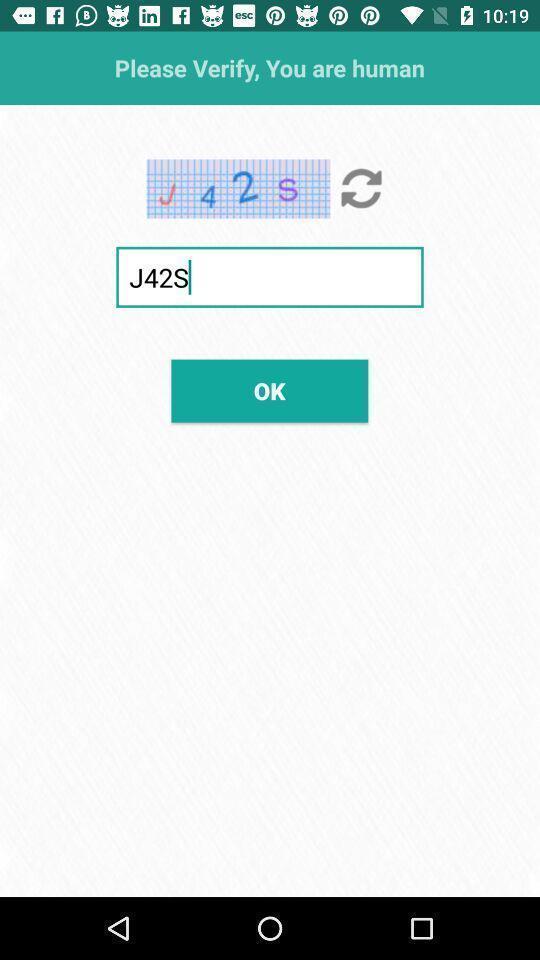Summarize the information in this screenshot. Page displays to verify whether human or not. 